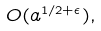<formula> <loc_0><loc_0><loc_500><loc_500>O ( a ^ { 1 / 2 + \epsilon } ) ,</formula> 